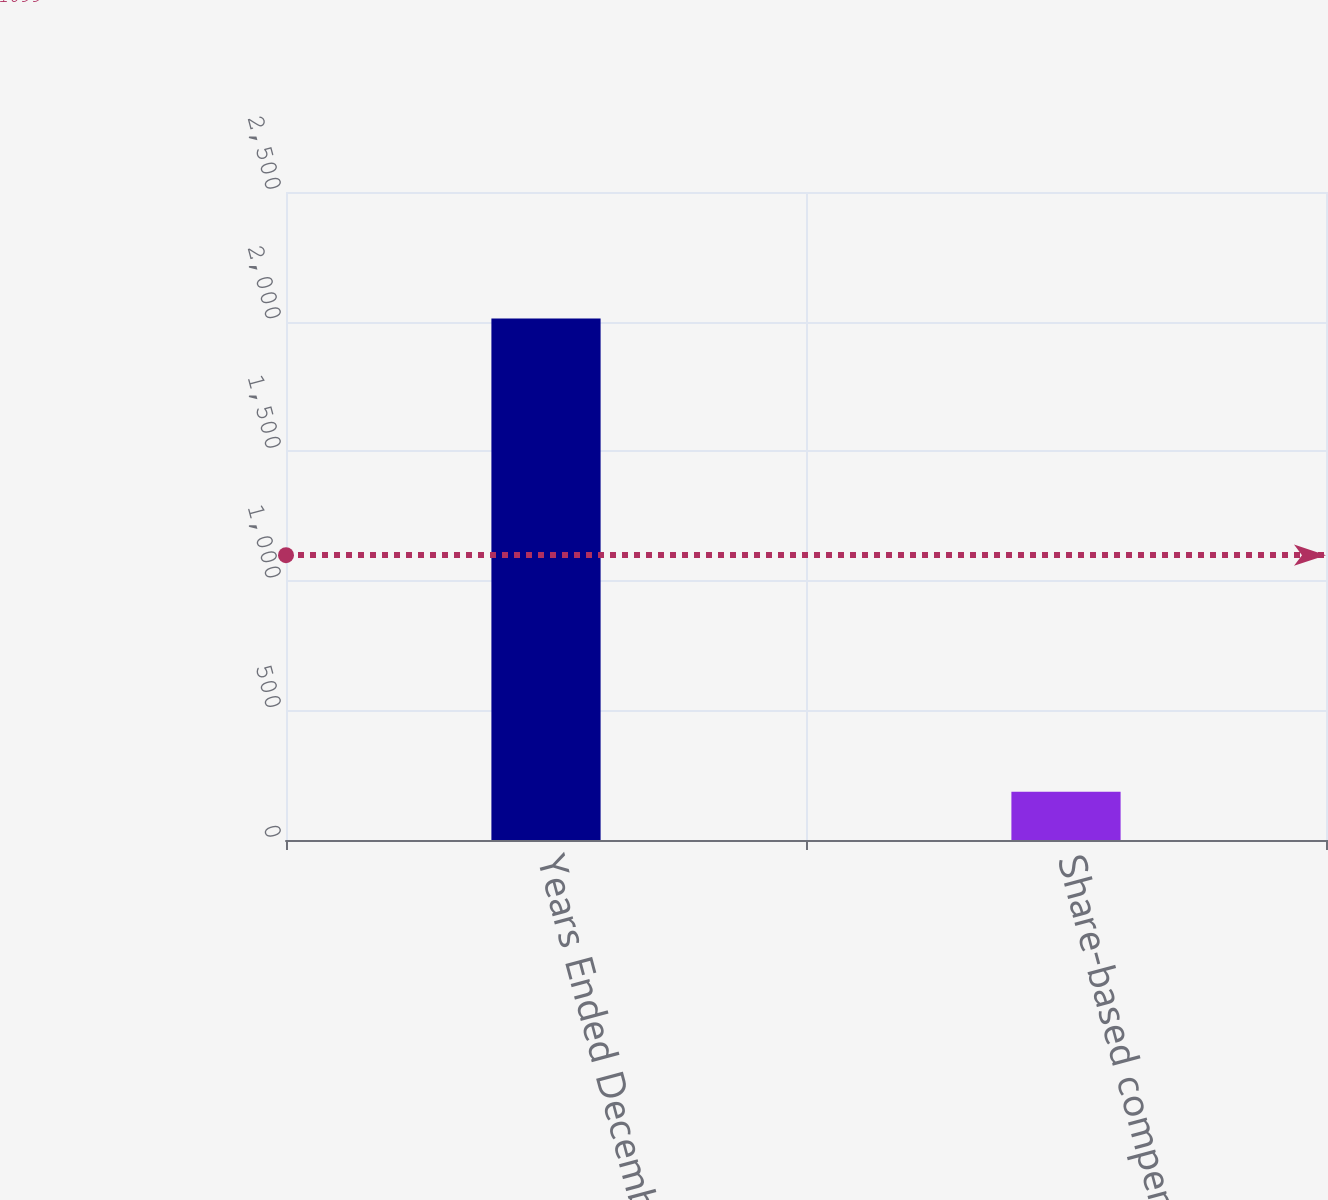Convert chart. <chart><loc_0><loc_0><loc_500><loc_500><bar_chart><fcel>Years Ended December 31 (in<fcel>Share-based compensation<nl><fcel>2012<fcel>186<nl></chart> 